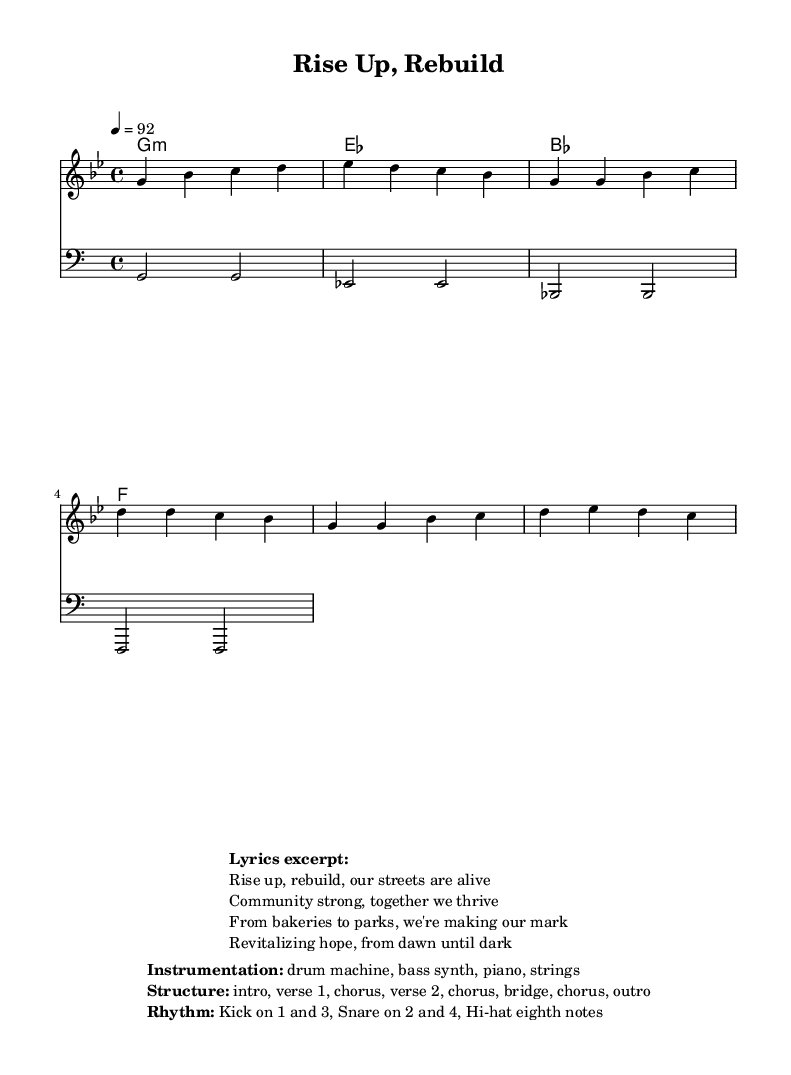What is the key signature of this music? The key signature is G minor, which includes two flats (B flat and E flat). This can be identified directly from the music sheet.
Answer: G minor What is the time signature of this music? The time signature is 4/4, meaning there are four beats in each measure and the quarter note receives one beat. This is noted at the beginning of the score.
Answer: 4/4 What is the tempo marking for this piece? The tempo marking is 92 beats per minute, indicated by the tempo notation in the score. This tells the performer how fast the music should be played.
Answer: 92 How many bars are there in the chorus section? The chorus section contains four measures. This can be identified by counting the measures in the scored portion labeled as the "Chorus."
Answer: 4 What instruments are used in this piece? The instruments listed are drum machine, bass synth, piano, and strings, as specified in the instrumentation section of the markup.
Answer: drum machine, bass synth, piano, strings What is the structure of the music? The structure follows the layout of intro, verse 1, chorus, verse 2, chorus, bridge, chorus, and outro, outlined in the score's markup.
Answer: intro, verse 1, chorus, verse 2, chorus, bridge, chorus, outro How does the rhythm of the piece function? The rhythm features a kick drum on beats one and three, a snare on beats two and four, and eighth note hi-hats, reflecting a typical rap beat structure. This is described in the rhythm section of the markup.
Answer: Kick on 1 and 3, Snare on 2 and 4, Hi-hat eighth notes 